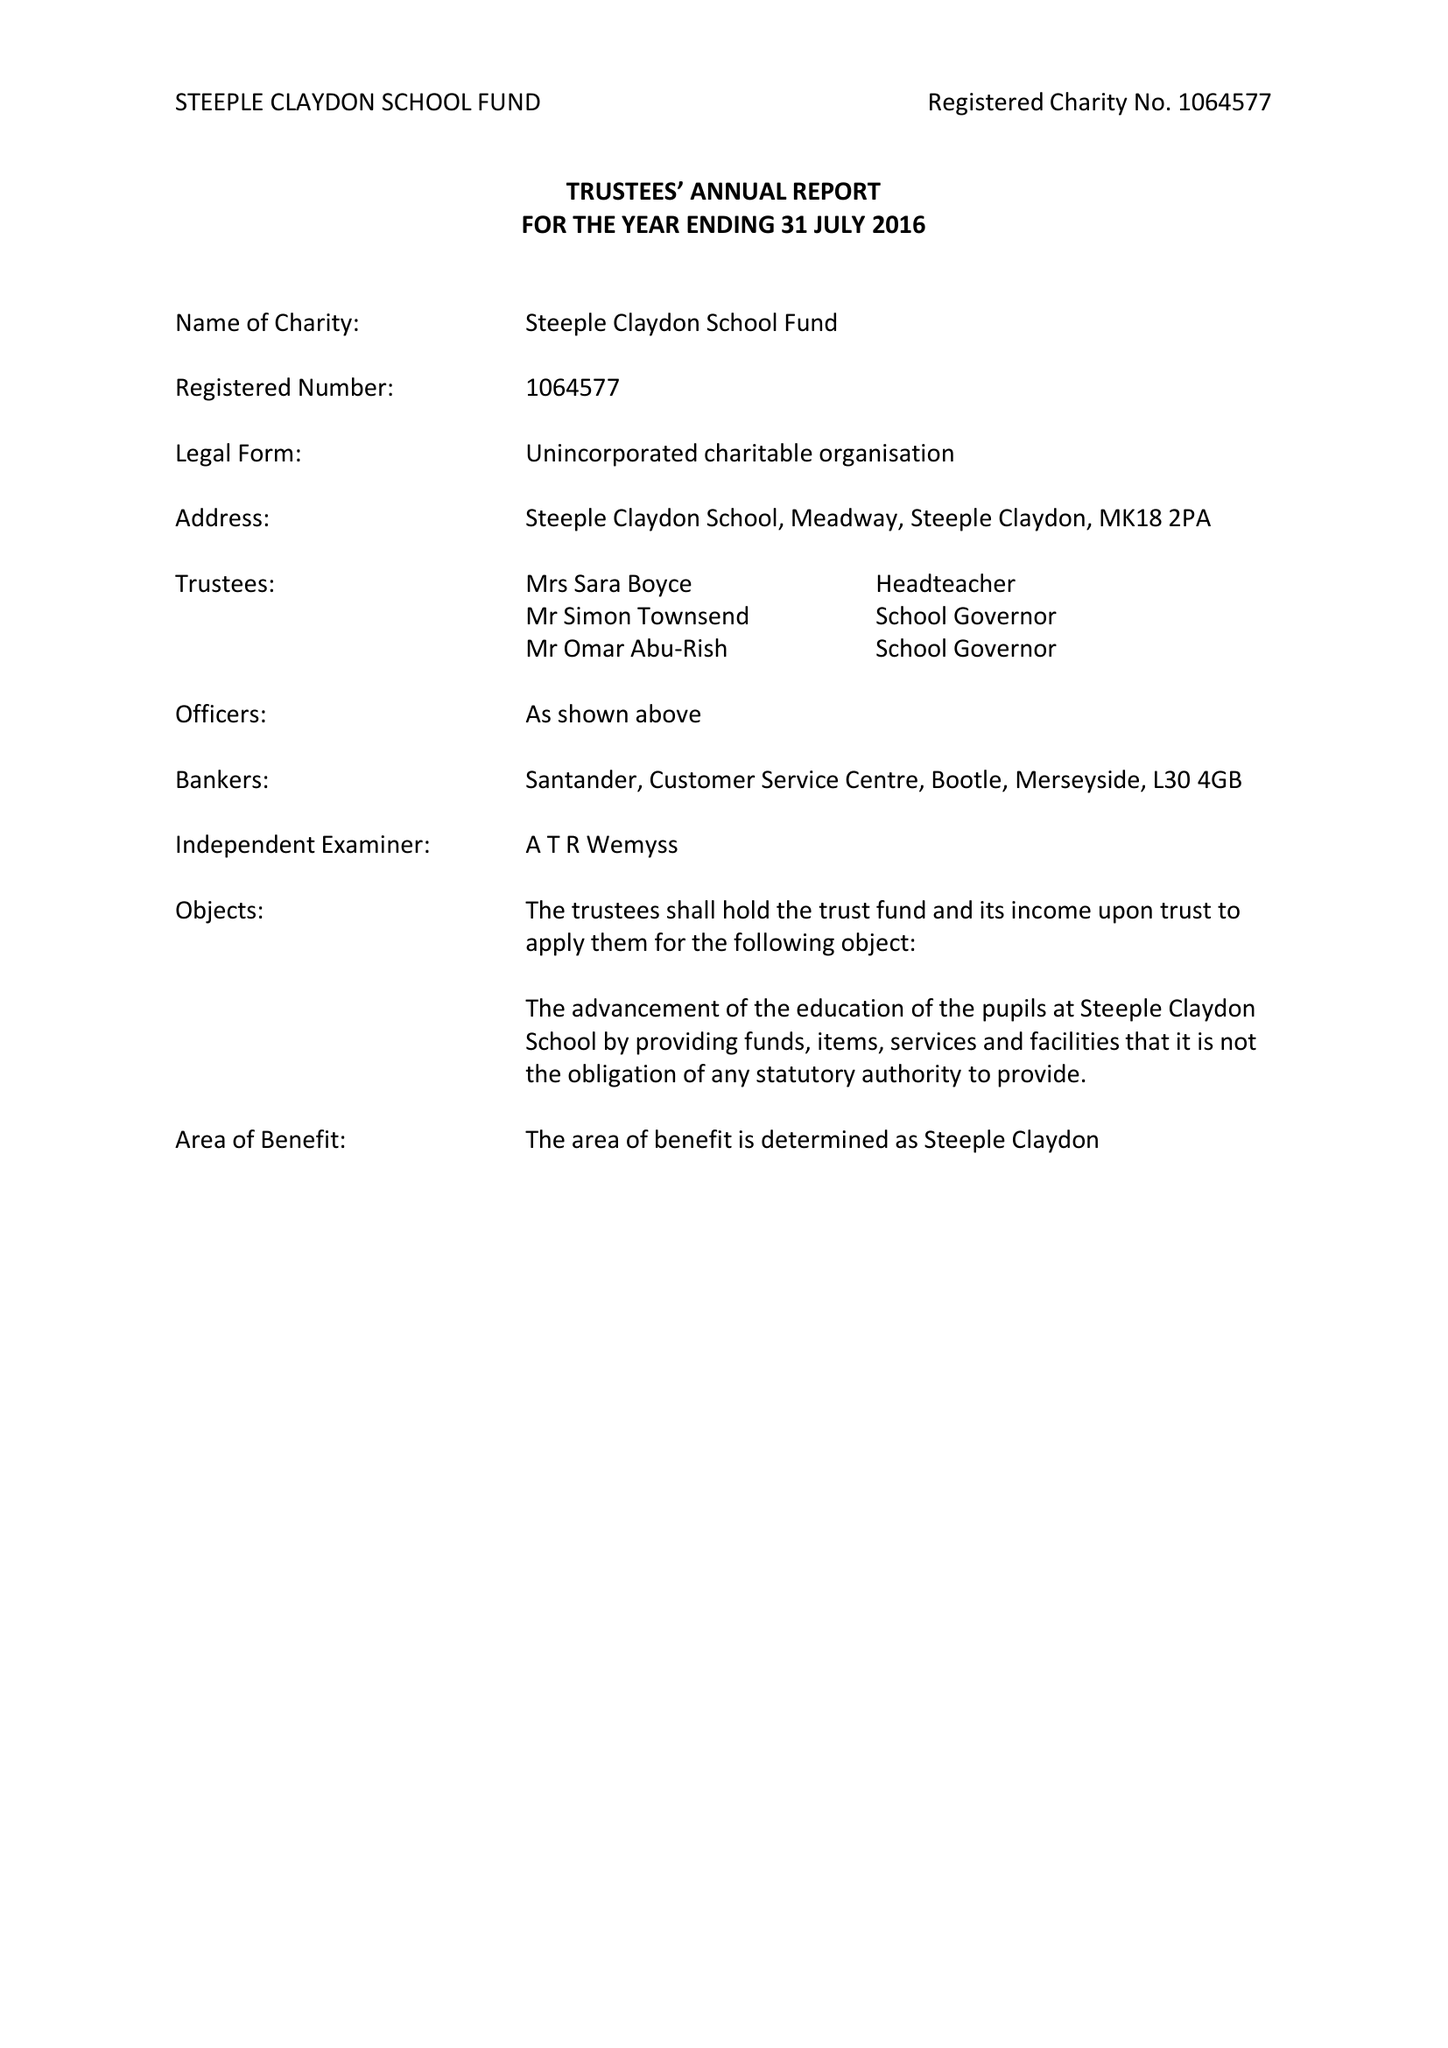What is the value for the charity_number?
Answer the question using a single word or phrase. 1064577 